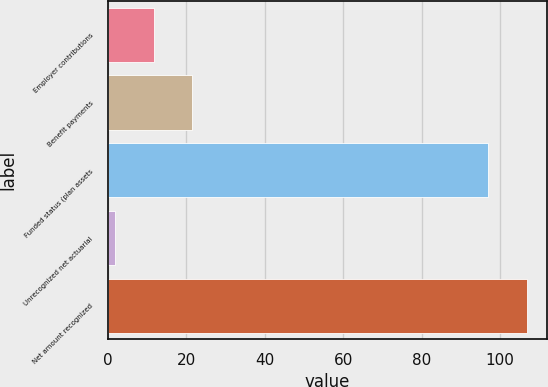Convert chart. <chart><loc_0><loc_0><loc_500><loc_500><bar_chart><fcel>Employer contributions<fcel>Benefit payments<fcel>Funded status (plan assets<fcel>Unrecognized net actuarial<fcel>Net amount recognized<nl><fcel>11.7<fcel>21.4<fcel>97<fcel>2<fcel>106.7<nl></chart> 